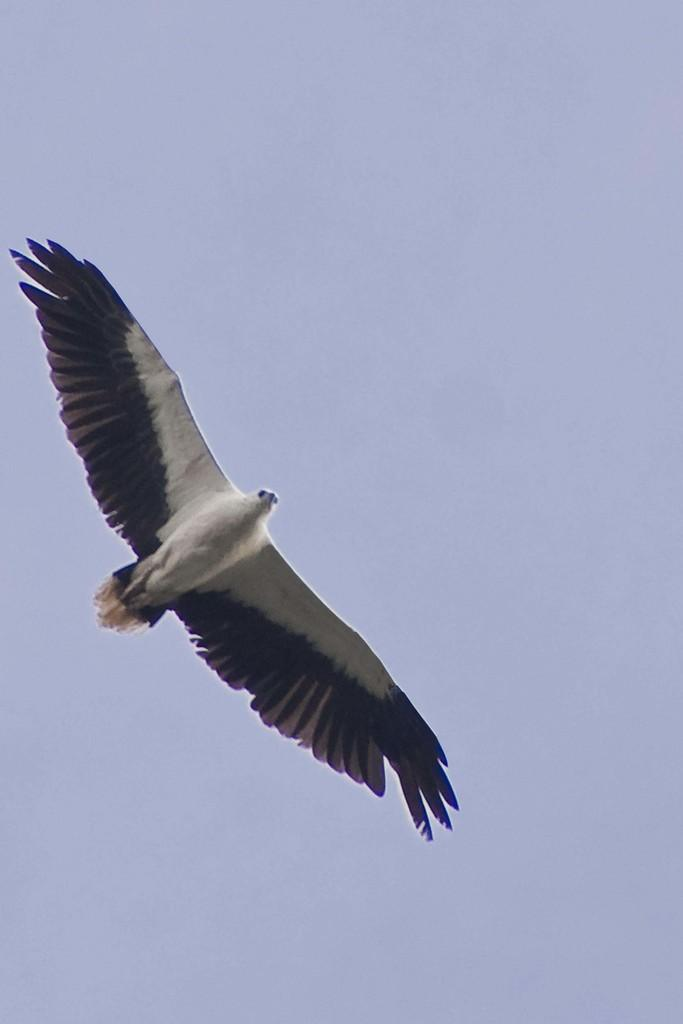What type of animal can be seen in the image? There is a bird in the image. What is the bird doing in the image? The bird is flying. What can be seen in the background of the image? The sky is visible in the background of the image. What type of comb is the bird using to groom its feathers in the image? There is no comb present in the image, and the bird is not grooming its feathers. 